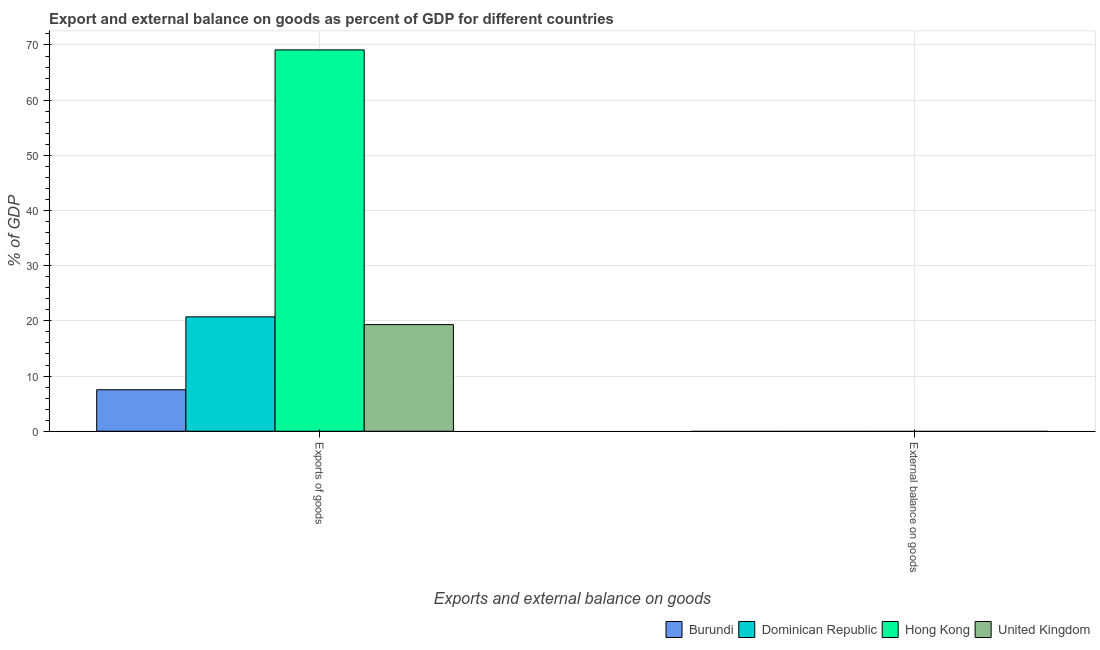Are the number of bars on each tick of the X-axis equal?
Keep it short and to the point. No. How many bars are there on the 1st tick from the left?
Keep it short and to the point. 4. What is the label of the 1st group of bars from the left?
Make the answer very short. Exports of goods. What is the export of goods as percentage of gdp in United Kingdom?
Make the answer very short. 19.32. Across all countries, what is the maximum export of goods as percentage of gdp?
Keep it short and to the point. 69.11. Across all countries, what is the minimum export of goods as percentage of gdp?
Your response must be concise. 7.52. In which country was the export of goods as percentage of gdp maximum?
Make the answer very short. Hong Kong. What is the total export of goods as percentage of gdp in the graph?
Provide a short and direct response. 116.68. What is the difference between the export of goods as percentage of gdp in Burundi and that in Hong Kong?
Your response must be concise. -61.59. What is the difference between the export of goods as percentage of gdp in Dominican Republic and the external balance on goods as percentage of gdp in Burundi?
Your answer should be compact. 20.73. What is the average export of goods as percentage of gdp per country?
Offer a terse response. 29.17. What is the ratio of the export of goods as percentage of gdp in Burundi to that in Hong Kong?
Make the answer very short. 0.11. Is the export of goods as percentage of gdp in Burundi less than that in United Kingdom?
Keep it short and to the point. Yes. In how many countries, is the export of goods as percentage of gdp greater than the average export of goods as percentage of gdp taken over all countries?
Give a very brief answer. 1. Are all the bars in the graph horizontal?
Your answer should be compact. No. How many countries are there in the graph?
Make the answer very short. 4. Are the values on the major ticks of Y-axis written in scientific E-notation?
Keep it short and to the point. No. Does the graph contain any zero values?
Make the answer very short. Yes. How are the legend labels stacked?
Make the answer very short. Horizontal. What is the title of the graph?
Keep it short and to the point. Export and external balance on goods as percent of GDP for different countries. What is the label or title of the X-axis?
Make the answer very short. Exports and external balance on goods. What is the label or title of the Y-axis?
Provide a short and direct response. % of GDP. What is the % of GDP of Burundi in Exports of goods?
Provide a short and direct response. 7.52. What is the % of GDP in Dominican Republic in Exports of goods?
Give a very brief answer. 20.73. What is the % of GDP in Hong Kong in Exports of goods?
Your answer should be very brief. 69.11. What is the % of GDP in United Kingdom in Exports of goods?
Offer a terse response. 19.32. What is the % of GDP of Dominican Republic in External balance on goods?
Offer a terse response. 0. What is the % of GDP in Hong Kong in External balance on goods?
Ensure brevity in your answer.  0. What is the % of GDP of United Kingdom in External balance on goods?
Your answer should be compact. 0. Across all Exports and external balance on goods, what is the maximum % of GDP of Burundi?
Your answer should be compact. 7.52. Across all Exports and external balance on goods, what is the maximum % of GDP of Dominican Republic?
Provide a short and direct response. 20.73. Across all Exports and external balance on goods, what is the maximum % of GDP of Hong Kong?
Keep it short and to the point. 69.11. Across all Exports and external balance on goods, what is the maximum % of GDP of United Kingdom?
Your answer should be very brief. 19.32. Across all Exports and external balance on goods, what is the minimum % of GDP in Dominican Republic?
Offer a very short reply. 0. Across all Exports and external balance on goods, what is the minimum % of GDP in United Kingdom?
Provide a short and direct response. 0. What is the total % of GDP in Burundi in the graph?
Offer a very short reply. 7.52. What is the total % of GDP in Dominican Republic in the graph?
Ensure brevity in your answer.  20.73. What is the total % of GDP of Hong Kong in the graph?
Provide a succinct answer. 69.11. What is the total % of GDP in United Kingdom in the graph?
Your response must be concise. 19.32. What is the average % of GDP of Burundi per Exports and external balance on goods?
Provide a short and direct response. 3.76. What is the average % of GDP of Dominican Republic per Exports and external balance on goods?
Offer a very short reply. 10.36. What is the average % of GDP in Hong Kong per Exports and external balance on goods?
Give a very brief answer. 34.55. What is the average % of GDP in United Kingdom per Exports and external balance on goods?
Your response must be concise. 9.66. What is the difference between the % of GDP in Burundi and % of GDP in Dominican Republic in Exports of goods?
Offer a very short reply. -13.21. What is the difference between the % of GDP of Burundi and % of GDP of Hong Kong in Exports of goods?
Offer a terse response. -61.59. What is the difference between the % of GDP in Burundi and % of GDP in United Kingdom in Exports of goods?
Keep it short and to the point. -11.81. What is the difference between the % of GDP of Dominican Republic and % of GDP of Hong Kong in Exports of goods?
Offer a terse response. -48.38. What is the difference between the % of GDP in Dominican Republic and % of GDP in United Kingdom in Exports of goods?
Keep it short and to the point. 1.4. What is the difference between the % of GDP in Hong Kong and % of GDP in United Kingdom in Exports of goods?
Your answer should be compact. 49.79. What is the difference between the highest and the lowest % of GDP in Burundi?
Offer a terse response. 7.52. What is the difference between the highest and the lowest % of GDP in Dominican Republic?
Keep it short and to the point. 20.73. What is the difference between the highest and the lowest % of GDP of Hong Kong?
Keep it short and to the point. 69.11. What is the difference between the highest and the lowest % of GDP in United Kingdom?
Offer a very short reply. 19.32. 